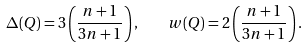Convert formula to latex. <formula><loc_0><loc_0><loc_500><loc_500>\Delta ( Q ) = 3 \left ( \frac { n + 1 } { 3 n + 1 } \right ) , \quad w ( Q ) = 2 \left ( \frac { n + 1 } { 3 n + 1 } \right ) .</formula> 